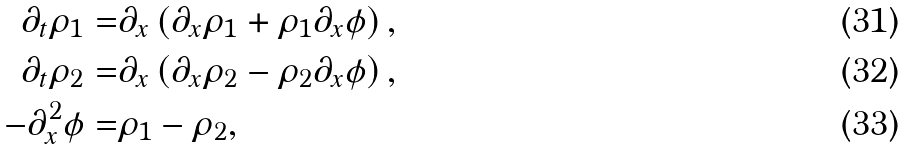<formula> <loc_0><loc_0><loc_500><loc_500>\partial _ { t } \rho _ { 1 } = & \partial _ { x } \left ( \partial _ { x } \rho _ { 1 } + \rho _ { 1 } \partial _ { x } \phi \right ) , \\ \partial _ { t } \rho _ { 2 } = & \partial _ { x } \left ( \partial _ { x } \rho _ { 2 } - \rho _ { 2 } \partial _ { x } \phi \right ) , \\ - \partial _ { x } ^ { 2 } \phi = & \rho _ { 1 } - \rho _ { 2 } ,</formula> 